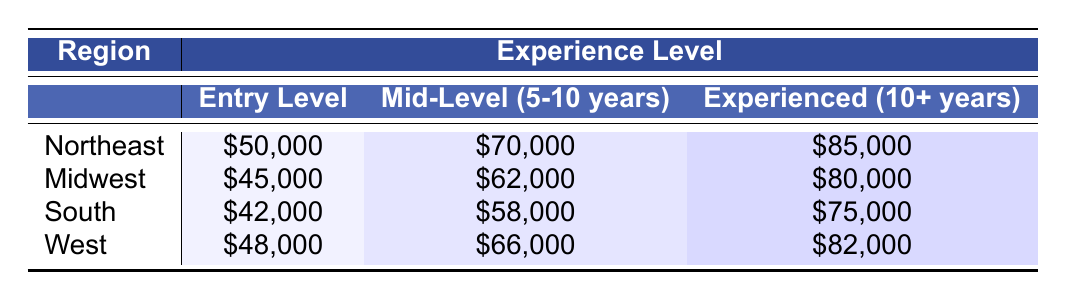What's the entry-level salary for teachers in the Northeast? According to the table, the entry-level salary for teachers in the Northeast is $50,000.
Answer: $50,000 Which region has the highest salary for experienced teachers? The table shows that the Northeast region has the highest salary for experienced teachers at $85,000.
Answer: Northeast What is the salary difference between mid-level teachers in the Midwest and the South? The mid-level salary in the Midwest is $62,000, and in the South, it's $58,000. The difference is $62,000 - $58,000 = $4,000.
Answer: $4,000 What is the average salary for entry-level teachers across all regions? To find the average, add the entry-level salaries: $50,000 (Northeast) + $45,000 (Midwest) + $42,000 (South) + $48,000 (West) = $185,000. Then divide by 4 (number of regions): $185,000 / 4 = $46,250.
Answer: $46,250 Is the entry-level salary in the South lower than in the West? The entry-level salary in the South is $42,000 and in the West is $48,000. Since $42,000 is less than $48,000, the statement is true.
Answer: Yes What is the total salary for experienced teachers in the Midwest and South combined? The experienced salary in the Midwest is $80,000 and in the South is $75,000. Combine these amounts: $80,000 + $75,000 = $155,000.
Answer: $155,000 Which experience level has the smallest salary in the South? The table shows that the entry-level salary is the smallest at $42,000 for the South.
Answer: Entry Level How much more do experienced teachers earn in the Northeast compared to entry-level teachers in the South? The experienced salary in the Northeast is $85,000, and the entry-level salary in the South is $42,000. The difference is $85,000 - $42,000 = $43,000.
Answer: $43,000 What is the range of salaries for mid-level teachers across all regions? The range is calculated by deducting the lowest mid-level salary, which is $58,000 (South), from the highest mid-level salary, which is $70,000 (Northeast): $70,000 - $58,000 = $12,000.
Answer: $12,000 If a teacher in the West advances from entry-level to experienced in 10 years, how much will their salary increase? The entry-level salary in the West is $48,000 and the experienced salary is $82,000. The increase is calculated as $82,000 - $48,000 = $34,000.
Answer: $34,000 